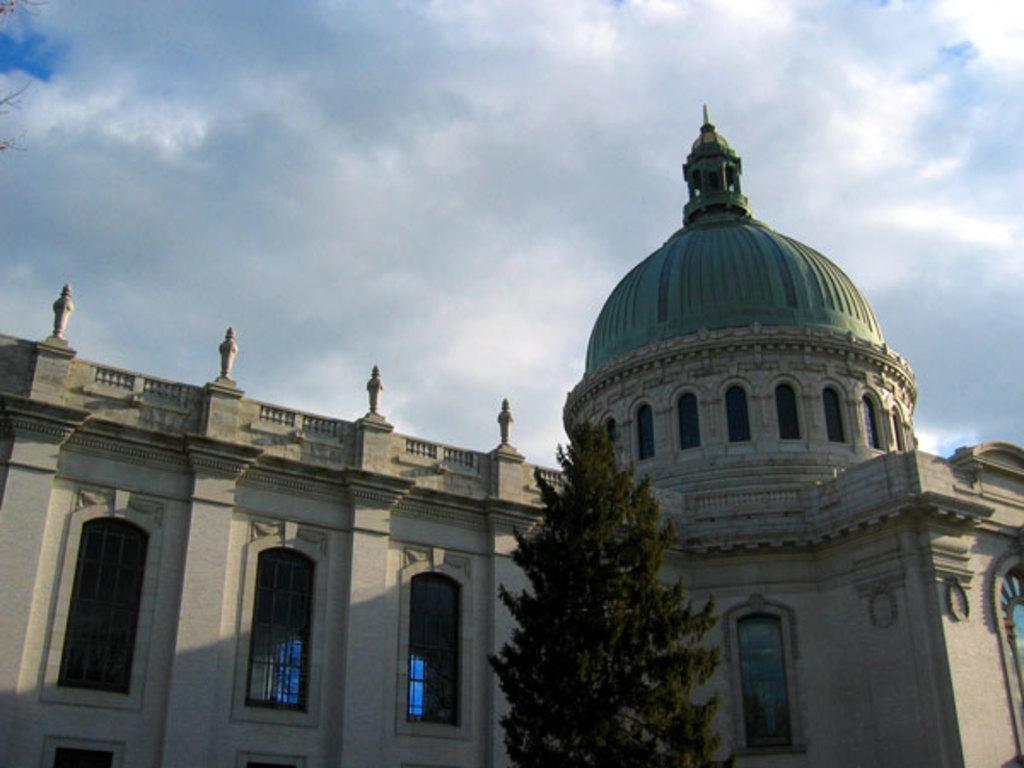Could you give a brief overview of what you see in this image? In the picture we can see a part of the palace building with glass windows and near it, we can see the tree and behind the building we can see the sky with clouds. 